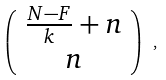<formula> <loc_0><loc_0><loc_500><loc_500>\left ( \begin{array} { c } \frac { N - F } { k } + n \\ n \end{array} \right ) \ ,</formula> 